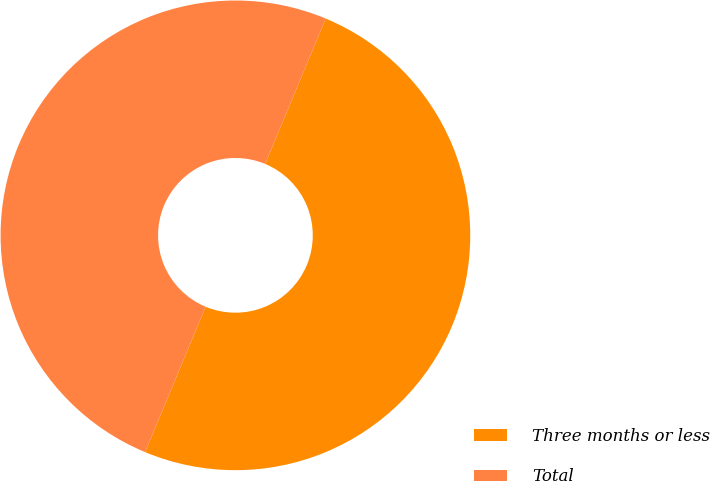<chart> <loc_0><loc_0><loc_500><loc_500><pie_chart><fcel>Three months or less<fcel>Total<nl><fcel>50.0%<fcel>50.0%<nl></chart> 